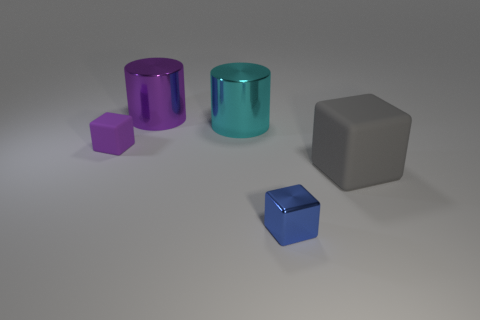What number of gray cubes have the same size as the purple metal cylinder?
Keep it short and to the point. 1. What number of things are behind the tiny block in front of the big block?
Offer a very short reply. 4. There is a cylinder in front of the purple metal thing; is its color the same as the small metallic cube?
Provide a short and direct response. No. Are there any tiny blue metal cubes that are behind the purple object that is in front of the large object that is behind the cyan thing?
Your answer should be very brief. No. What is the shape of the shiny object that is behind the tiny purple matte object and in front of the large purple thing?
Offer a very short reply. Cylinder. Is there a cube of the same color as the tiny shiny object?
Your response must be concise. No. What color is the matte cube behind the matte object that is in front of the tiny purple cube?
Make the answer very short. Purple. There is a purple object behind the matte thing that is on the left side of the purple thing that is behind the tiny matte block; what is its size?
Your answer should be compact. Large. Are the big cyan cylinder and the cube on the right side of the tiny blue block made of the same material?
Provide a succinct answer. No. What size is the thing that is made of the same material as the small purple block?
Your answer should be very brief. Large. 